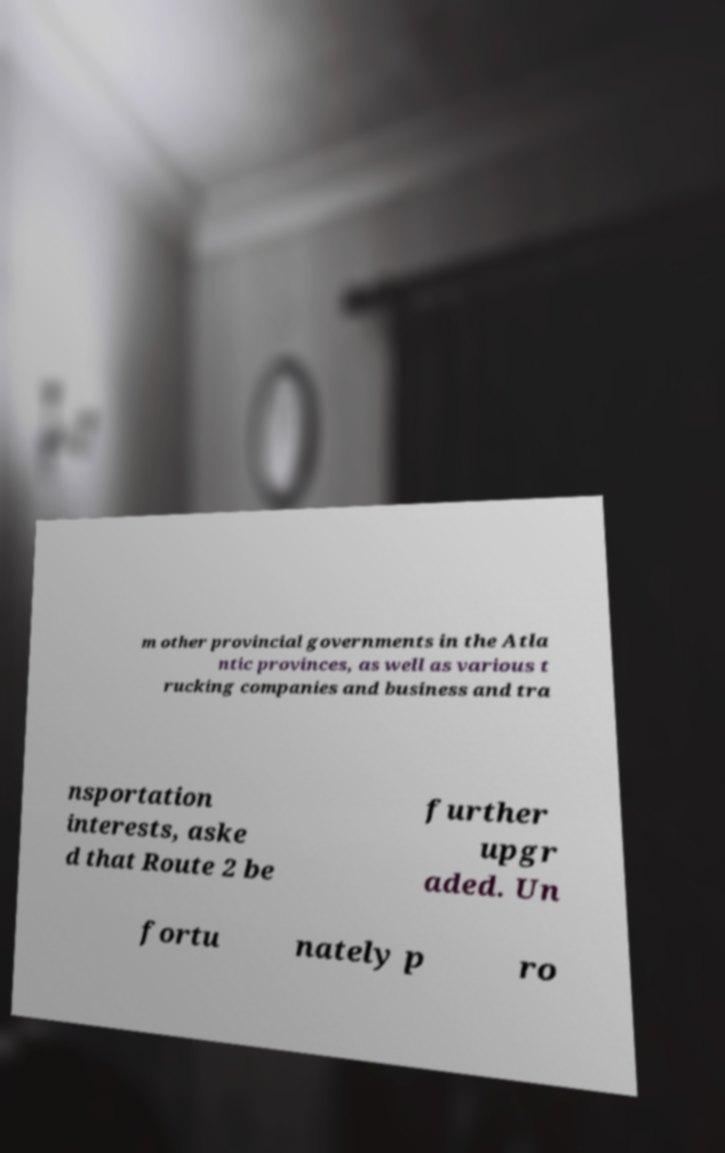For documentation purposes, I need the text within this image transcribed. Could you provide that? m other provincial governments in the Atla ntic provinces, as well as various t rucking companies and business and tra nsportation interests, aske d that Route 2 be further upgr aded. Un fortu nately p ro 